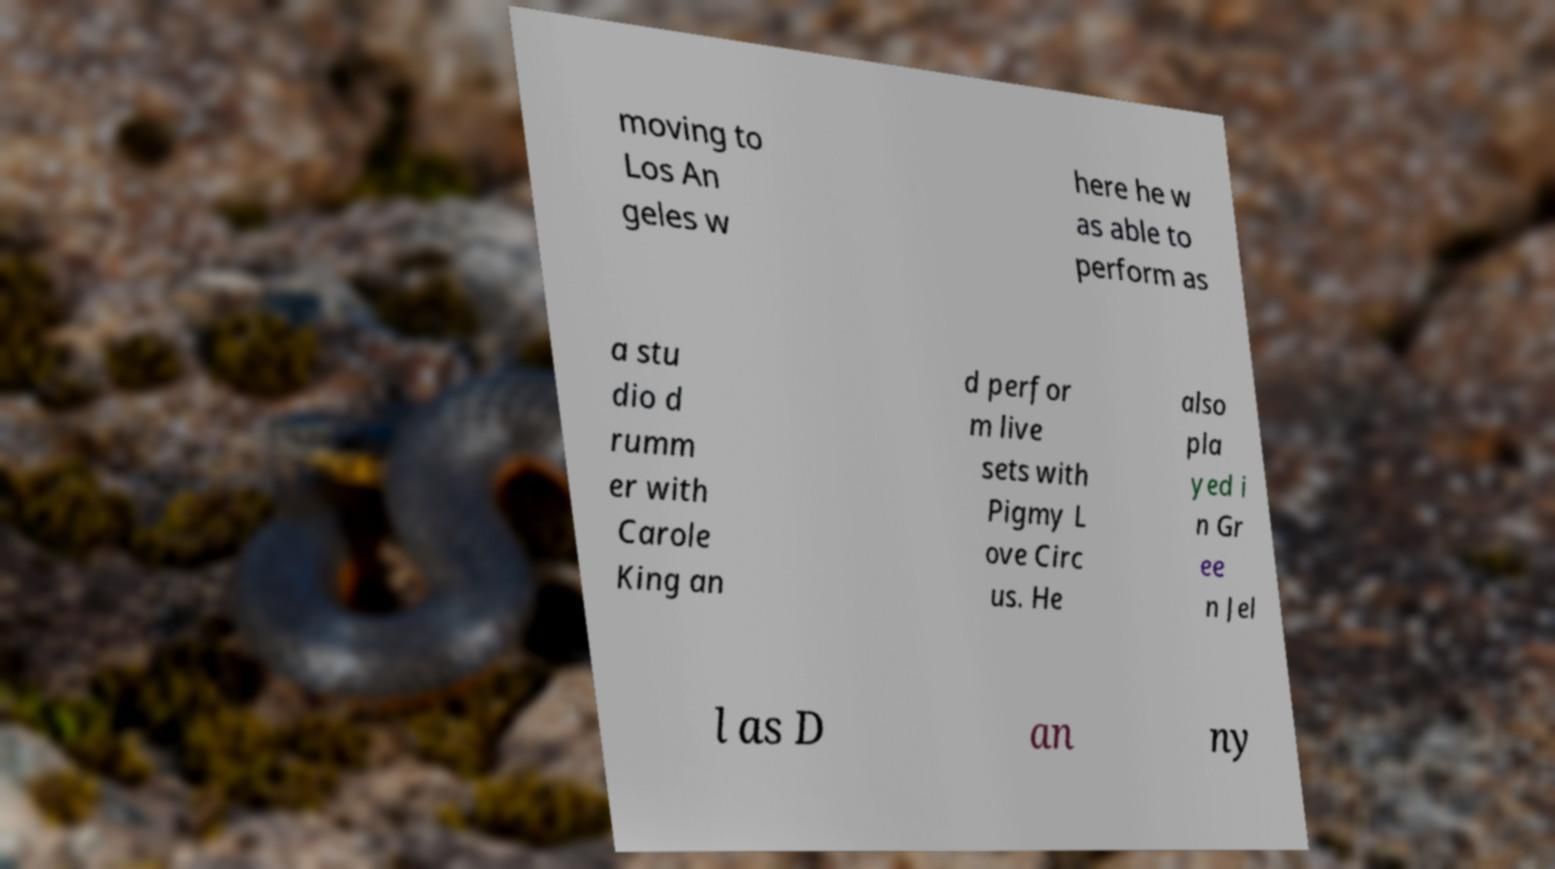Can you accurately transcribe the text from the provided image for me? moving to Los An geles w here he w as able to perform as a stu dio d rumm er with Carole King an d perfor m live sets with Pigmy L ove Circ us. He also pla yed i n Gr ee n Jel l as D an ny 